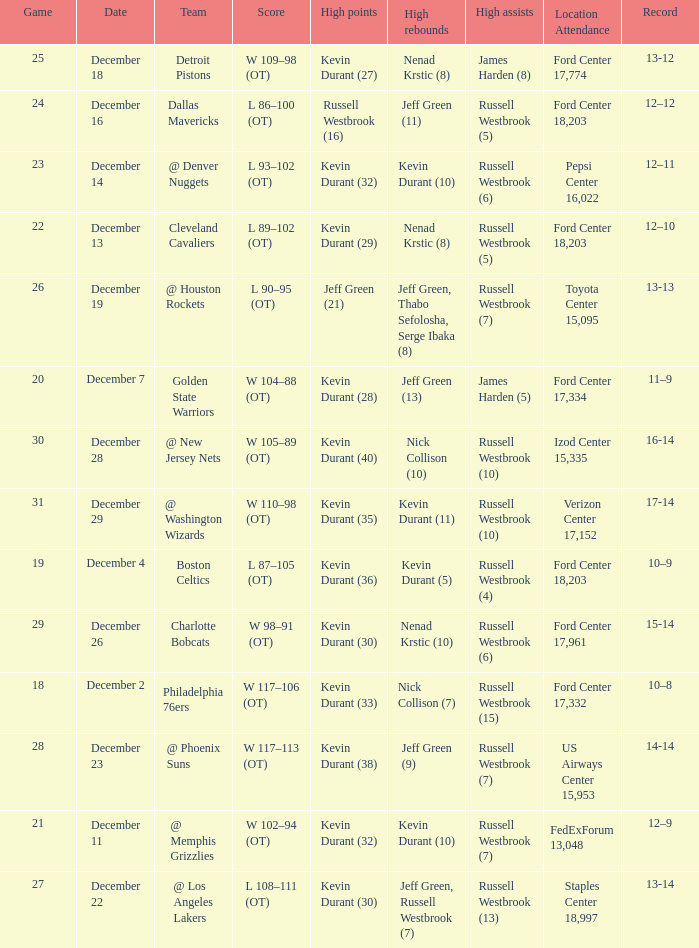Who has high points when toyota center 15,095 is location attendance? Jeff Green (21). 